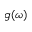Convert formula to latex. <formula><loc_0><loc_0><loc_500><loc_500>g ( \omega )</formula> 